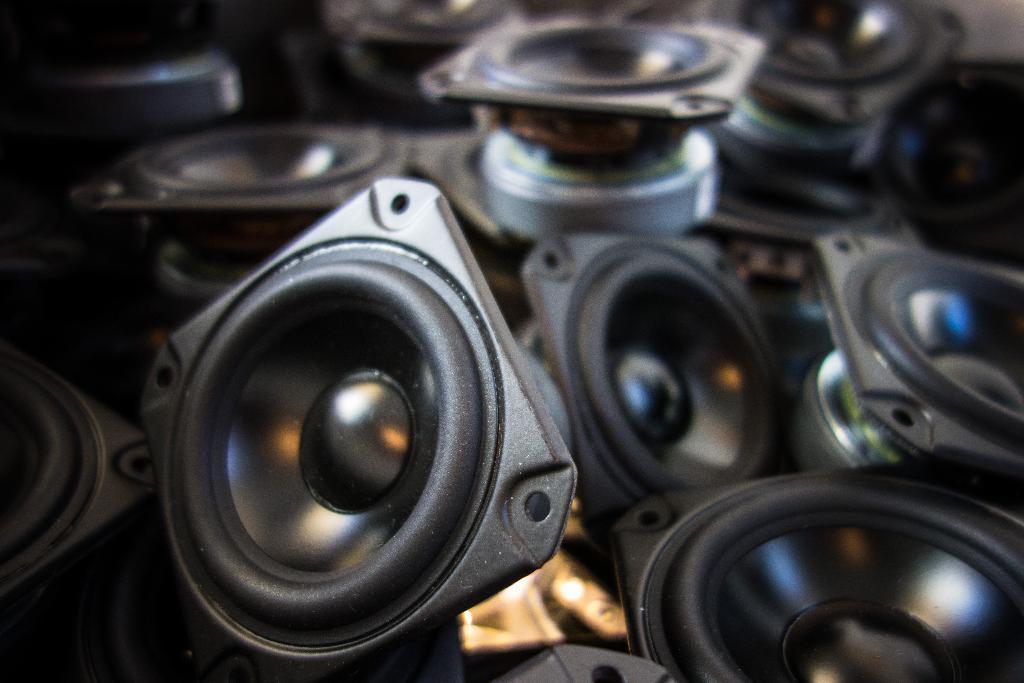Please provide a concise description of this image. In this image in the center there are some objects, and it looks like some devices. 